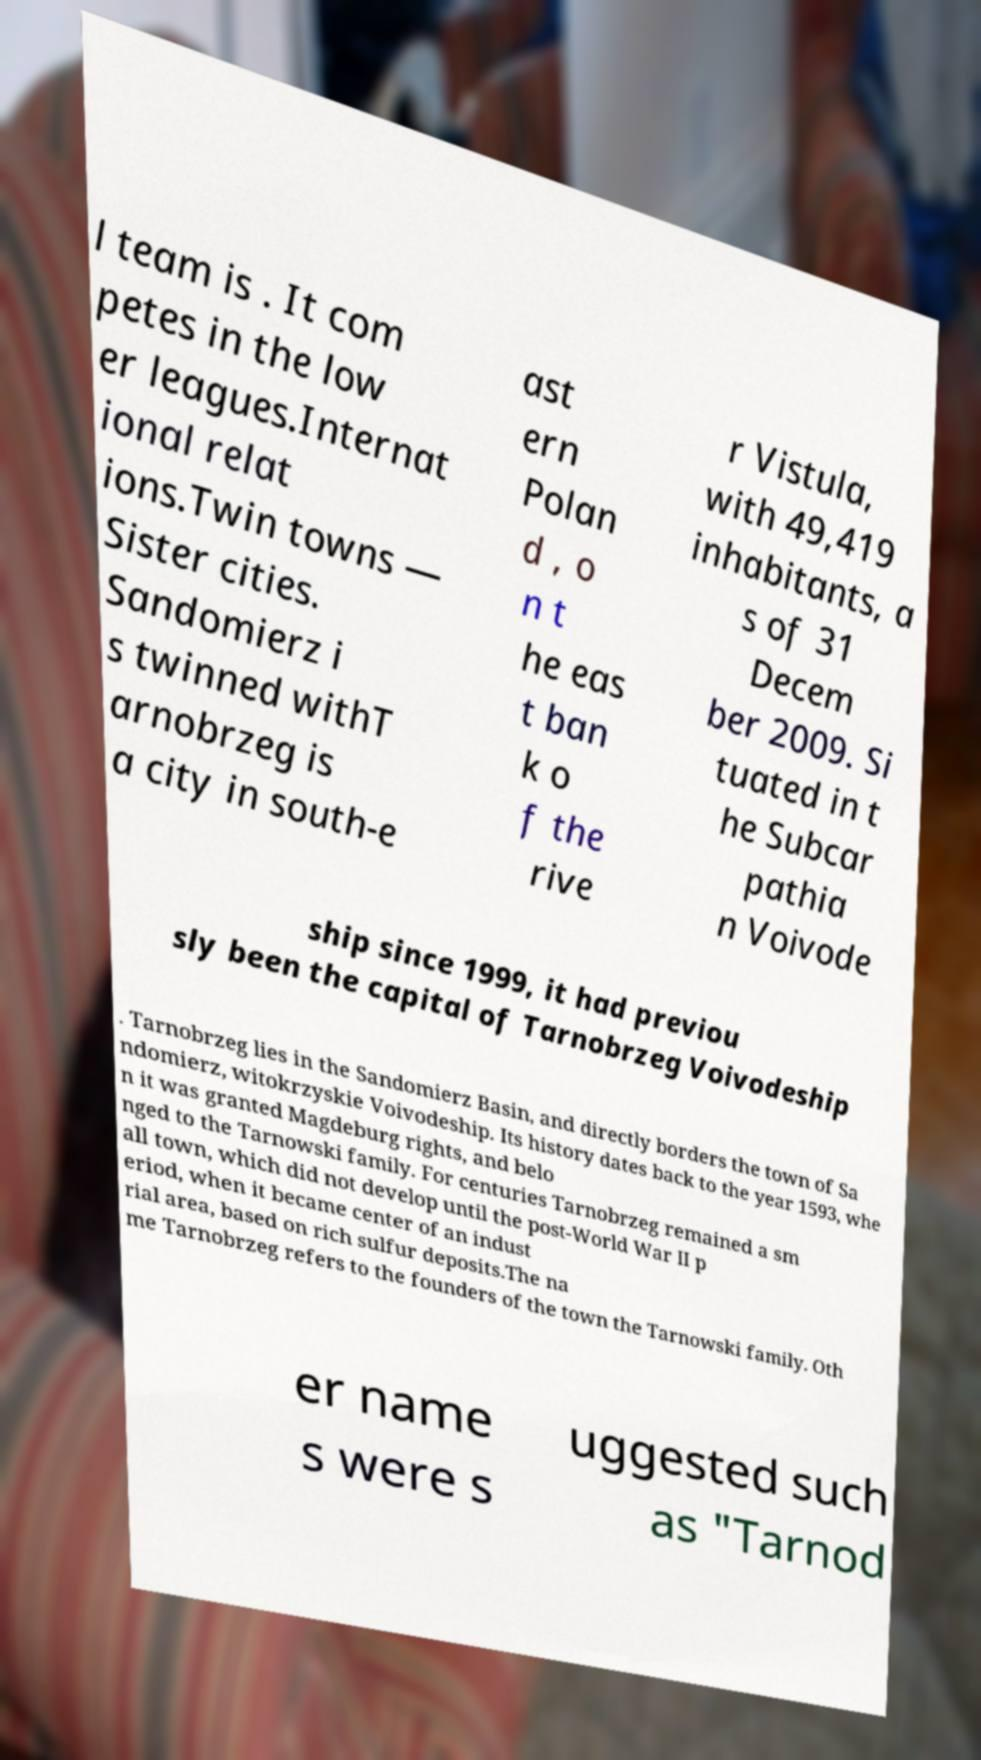I need the written content from this picture converted into text. Can you do that? l team is . It com petes in the low er leagues.Internat ional relat ions.Twin towns — Sister cities. Sandomierz i s twinned withT arnobrzeg is a city in south-e ast ern Polan d , o n t he eas t ban k o f the rive r Vistula, with 49,419 inhabitants, a s of 31 Decem ber 2009. Si tuated in t he Subcar pathia n Voivode ship since 1999, it had previou sly been the capital of Tarnobrzeg Voivodeship . Tarnobrzeg lies in the Sandomierz Basin, and directly borders the town of Sa ndomierz, witokrzyskie Voivodeship. Its history dates back to the year 1593, whe n it was granted Magdeburg rights, and belo nged to the Tarnowski family. For centuries Tarnobrzeg remained a sm all town, which did not develop until the post-World War II p eriod, when it became center of an indust rial area, based on rich sulfur deposits.The na me Tarnobrzeg refers to the founders of the town the Tarnowski family. Oth er name s were s uggested such as "Tarnod 